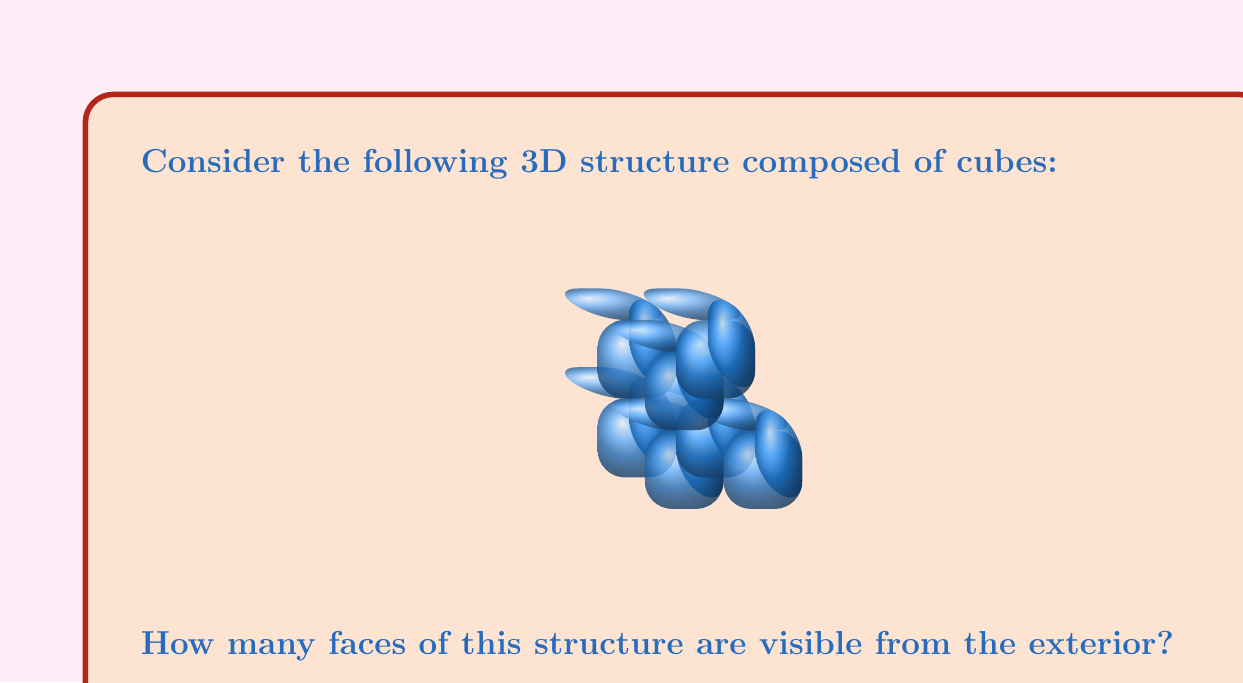What is the answer to this math problem? Let's approach this step-by-step:

1) First, we need to understand what constitutes a visible face. A face is visible if it's on the exterior of the structure and not hidden by another cube.

2) Let's count the visible faces for each side of the structure:

   - Top: 3 faces are visible
   - Bottom: 1 face is visible (the bottom of the base cube)
   - Front: 4 faces are visible
   - Back: 2 faces are visible
   - Left: 3 faces are visible
   - Right: 2 faces are visible

3) Now, let's sum up all these visible faces:

   $$3 + 1 + 4 + 2 + 3 + 2 = 15$$

4) However, we need to be careful not to double-count the edges where two visible faces meet. In this case, all the edges we've counted are indeed unique visible faces.

5) Therefore, the total number of visible faces is 15.
Answer: 15 